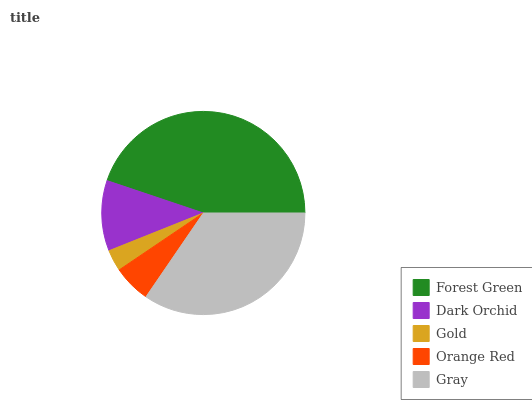Is Gold the minimum?
Answer yes or no. Yes. Is Forest Green the maximum?
Answer yes or no. Yes. Is Dark Orchid the minimum?
Answer yes or no. No. Is Dark Orchid the maximum?
Answer yes or no. No. Is Forest Green greater than Dark Orchid?
Answer yes or no. Yes. Is Dark Orchid less than Forest Green?
Answer yes or no. Yes. Is Dark Orchid greater than Forest Green?
Answer yes or no. No. Is Forest Green less than Dark Orchid?
Answer yes or no. No. Is Dark Orchid the high median?
Answer yes or no. Yes. Is Dark Orchid the low median?
Answer yes or no. Yes. Is Orange Red the high median?
Answer yes or no. No. Is Orange Red the low median?
Answer yes or no. No. 